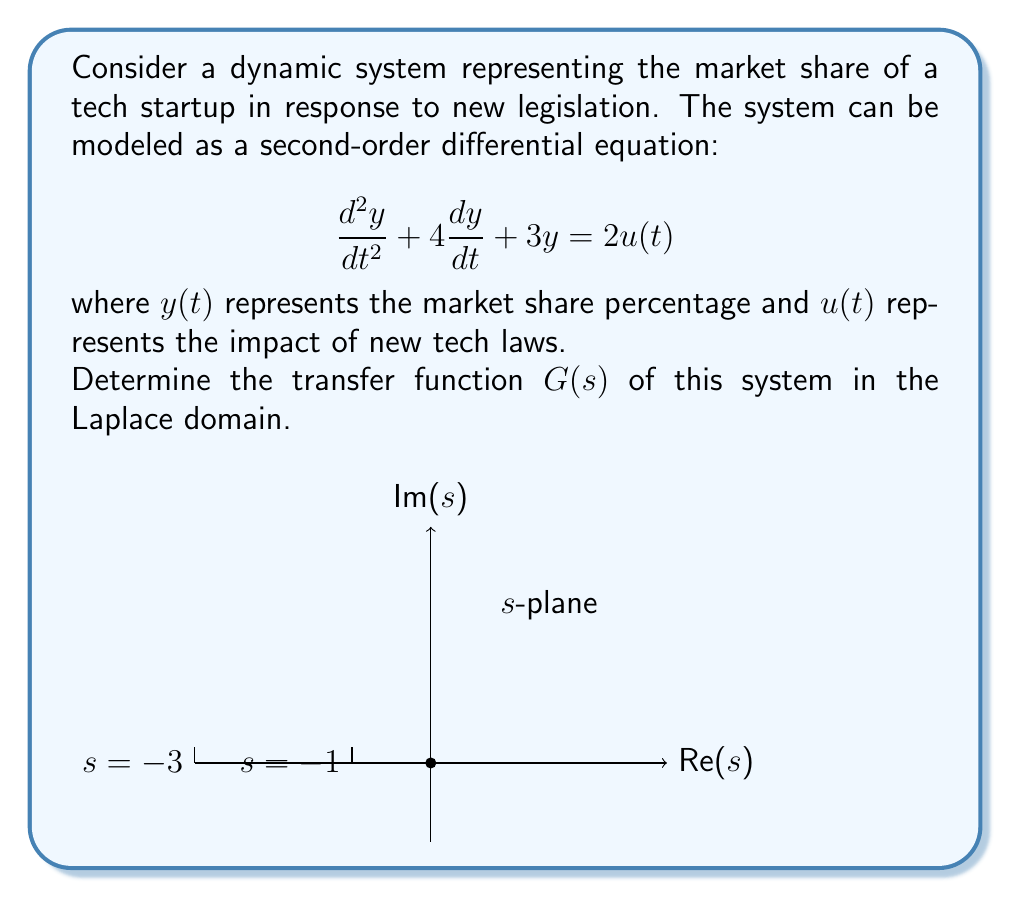Can you solve this math problem? To find the transfer function, we need to follow these steps:

1) First, take the Laplace transform of both sides of the equation:
   $$\mathcal{L}\{\frac{d^2y}{dt^2} + 4\frac{dy}{dt} + 3y\} = \mathcal{L}\{2u(t)\}$$

2) Using Laplace transform properties:
   $$s^2Y(s) - sy(0) - y'(0) + 4(sY(s) - y(0)) + 3Y(s) = 2U(s)$$

3) Assume zero initial conditions (y(0) = y'(0) = 0):
   $$s^2Y(s) + 4sY(s) + 3Y(s) = 2U(s)$$

4) Factor out Y(s):
   $$Y(s)(s^2 + 4s + 3) = 2U(s)$$

5) The transfer function G(s) is defined as the ratio of output Y(s) to input U(s):
   $$G(s) = \frac{Y(s)}{U(s)} = \frac{2}{s^2 + 4s + 3}$$

6) The denominator can be factored:
   $$G(s) = \frac{2}{(s+1)(s+3)}$$

This form shows that the system has two poles at s = -1 and s = -3, as illustrated in the s-plane diagram in the question.
Answer: $$G(s) = \frac{2}{(s+1)(s+3)}$$ 